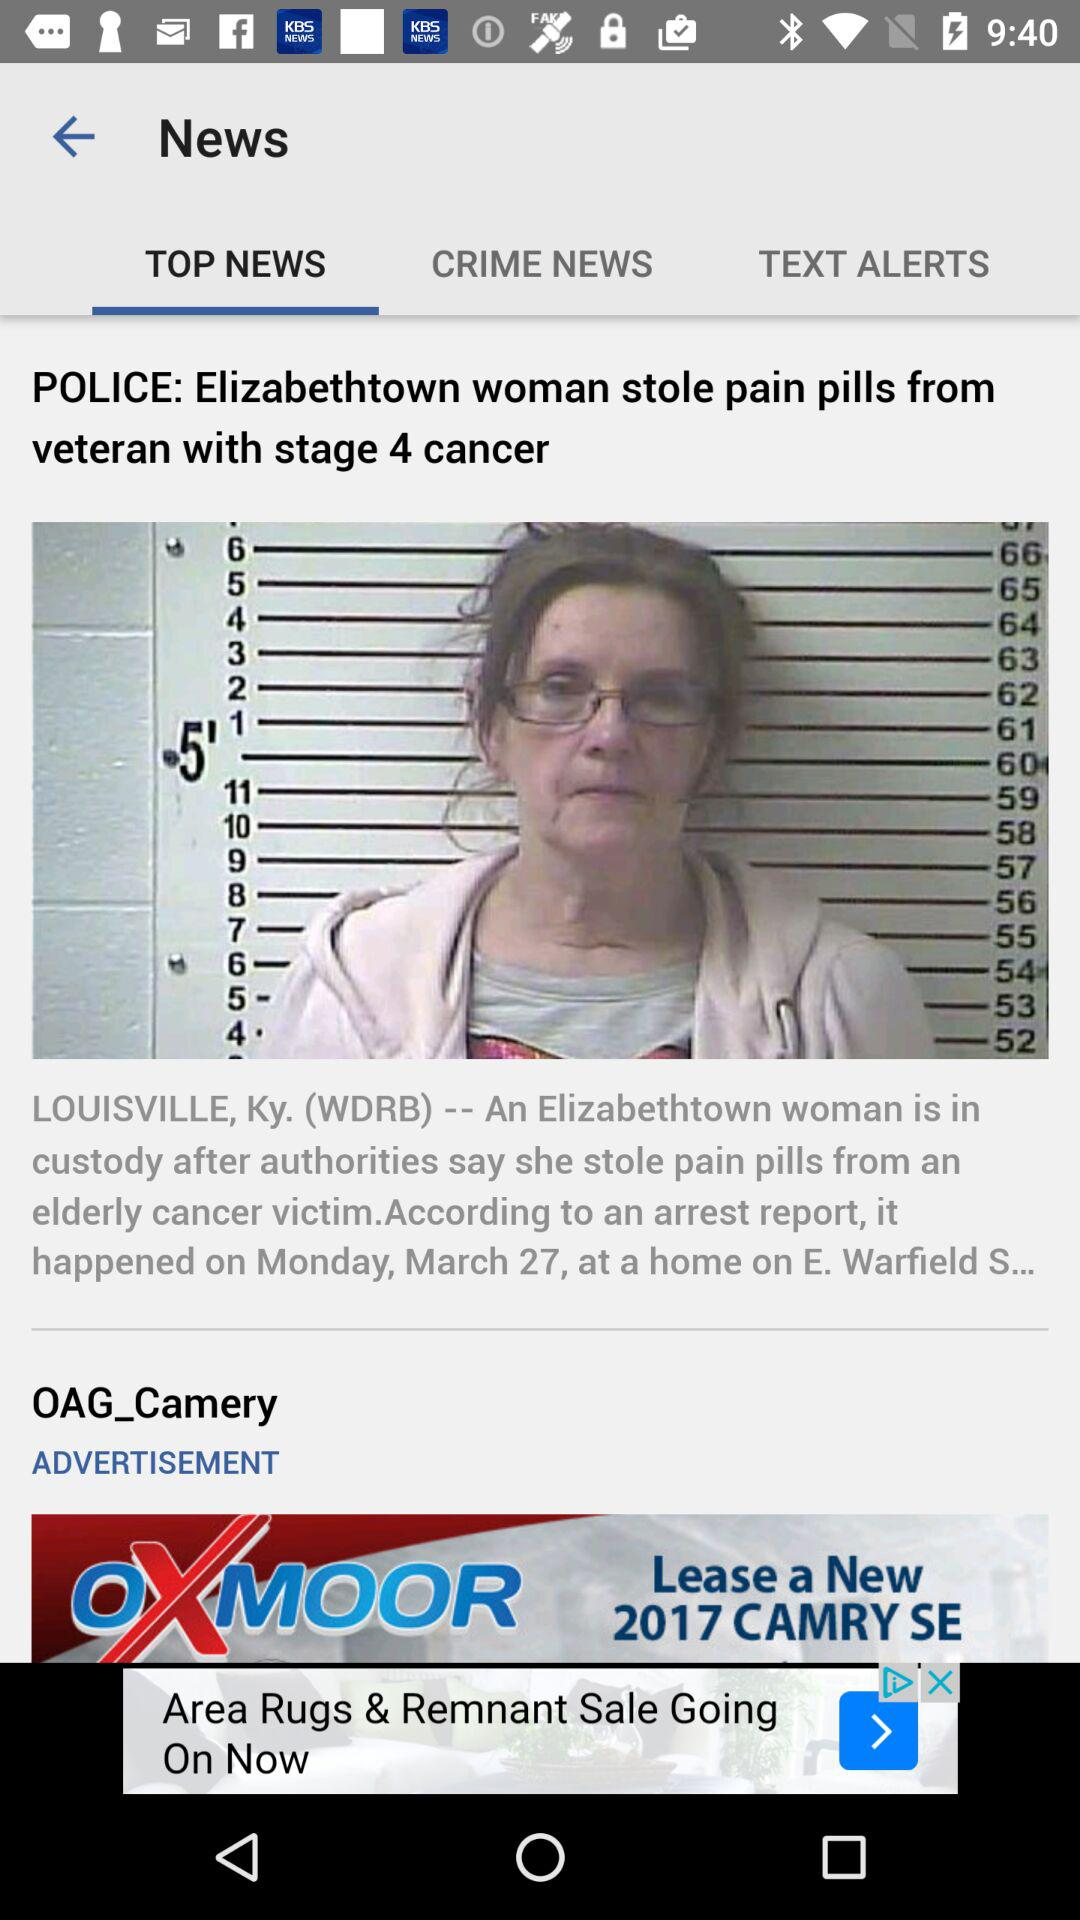Which tab is currently selected? The currently selected tab is "TOP NEWS". 